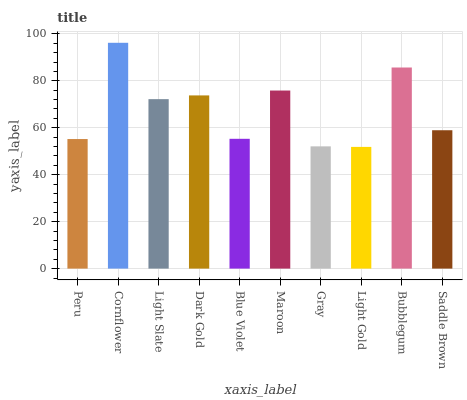Is Light Gold the minimum?
Answer yes or no. Yes. Is Cornflower the maximum?
Answer yes or no. Yes. Is Light Slate the minimum?
Answer yes or no. No. Is Light Slate the maximum?
Answer yes or no. No. Is Cornflower greater than Light Slate?
Answer yes or no. Yes. Is Light Slate less than Cornflower?
Answer yes or no. Yes. Is Light Slate greater than Cornflower?
Answer yes or no. No. Is Cornflower less than Light Slate?
Answer yes or no. No. Is Light Slate the high median?
Answer yes or no. Yes. Is Saddle Brown the low median?
Answer yes or no. Yes. Is Maroon the high median?
Answer yes or no. No. Is Blue Violet the low median?
Answer yes or no. No. 